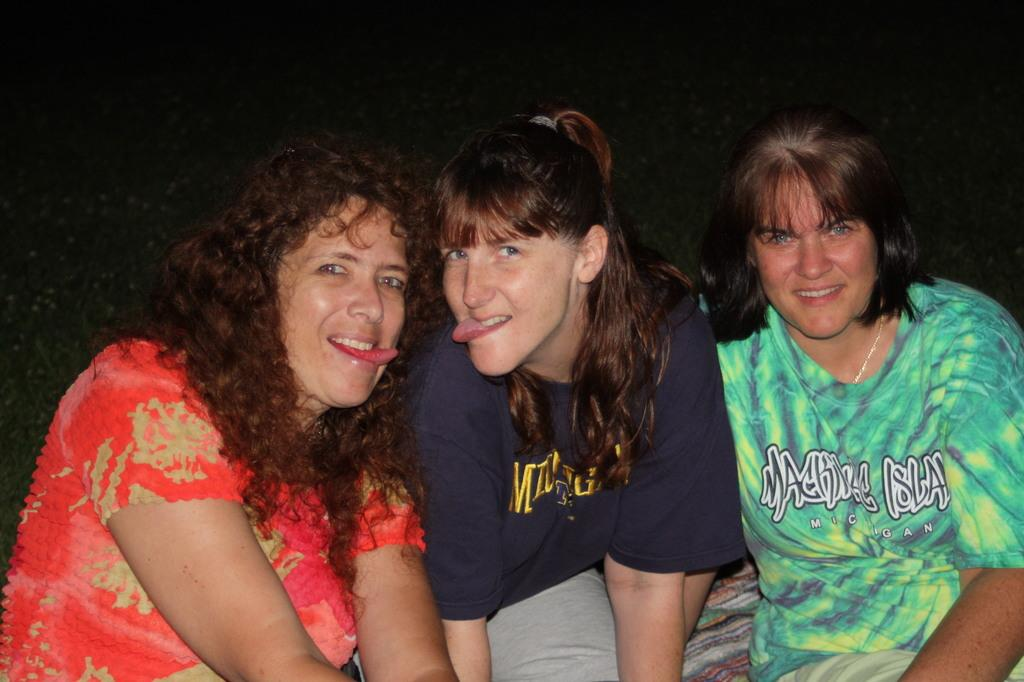How many people are in the image? There are three persons in the image. What can be observed about the background of the image? The background of the image is dark. What book are the persons reading in the image? There is no book present in the image, and the persons are not shown reading. What is the size of the base in the image? There is no base present in the image, so it is not possible to determine its size. 